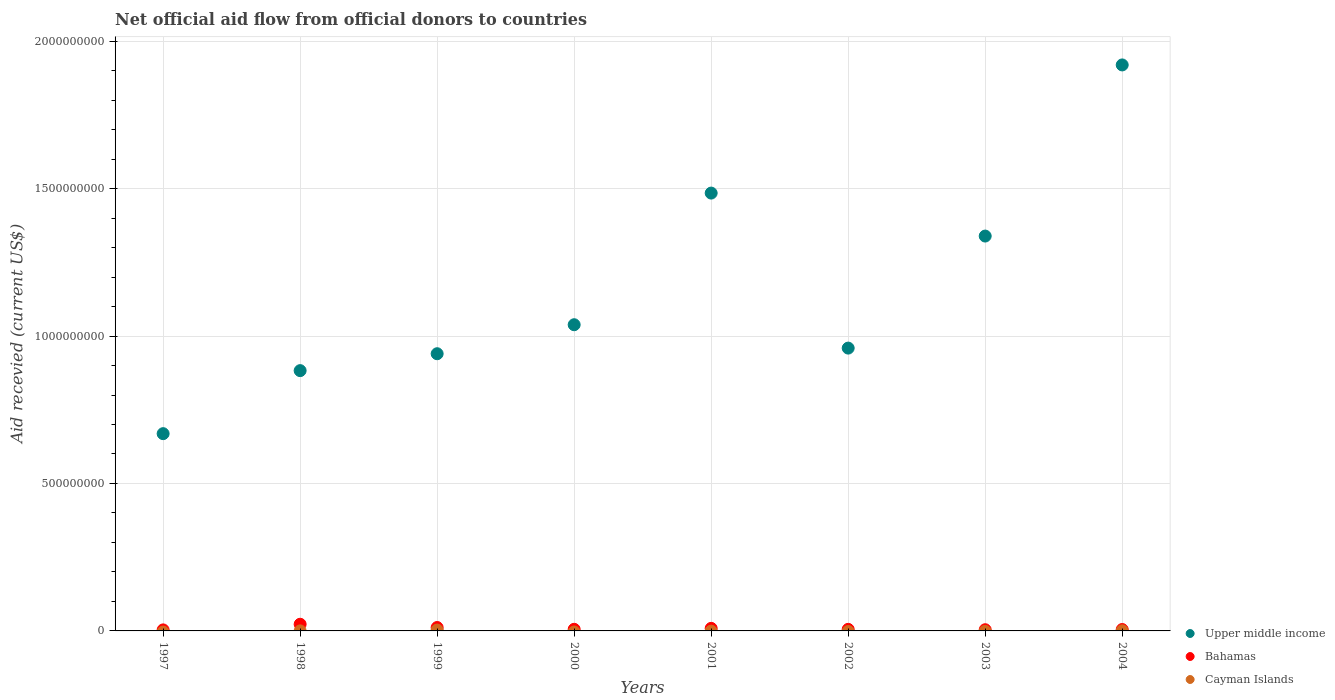Across all years, what is the maximum total aid received in Bahamas?
Your answer should be compact. 2.26e+07. What is the total total aid received in Upper middle income in the graph?
Provide a succinct answer. 9.23e+09. What is the difference between the total aid received in Upper middle income in 2001 and that in 2004?
Keep it short and to the point. -4.35e+08. What is the difference between the total aid received in Upper middle income in 2002 and the total aid received in Bahamas in 1997?
Offer a very short reply. 9.56e+08. What is the average total aid received in Upper middle income per year?
Provide a short and direct response. 1.15e+09. In the year 2004, what is the difference between the total aid received in Bahamas and total aid received in Cayman Islands?
Provide a succinct answer. 4.36e+06. What is the ratio of the total aid received in Bahamas in 2002 to that in 2003?
Give a very brief answer. 1.31. Is the total aid received in Bahamas in 1999 less than that in 2003?
Give a very brief answer. No. What is the difference between the highest and the second highest total aid received in Upper middle income?
Offer a terse response. 4.35e+08. What is the difference between the highest and the lowest total aid received in Upper middle income?
Your answer should be compact. 1.25e+09. Is it the case that in every year, the sum of the total aid received in Cayman Islands and total aid received in Bahamas  is greater than the total aid received in Upper middle income?
Provide a short and direct response. No. Does the total aid received in Upper middle income monotonically increase over the years?
Give a very brief answer. No. Is the total aid received in Upper middle income strictly greater than the total aid received in Bahamas over the years?
Ensure brevity in your answer.  Yes. How many years are there in the graph?
Ensure brevity in your answer.  8. What is the difference between two consecutive major ticks on the Y-axis?
Ensure brevity in your answer.  5.00e+08. Are the values on the major ticks of Y-axis written in scientific E-notation?
Give a very brief answer. No. Does the graph contain grids?
Make the answer very short. Yes. Where does the legend appear in the graph?
Keep it short and to the point. Bottom right. How many legend labels are there?
Give a very brief answer. 3. What is the title of the graph?
Keep it short and to the point. Net official aid flow from official donors to countries. Does "Central African Republic" appear as one of the legend labels in the graph?
Keep it short and to the point. No. What is the label or title of the X-axis?
Give a very brief answer. Years. What is the label or title of the Y-axis?
Make the answer very short. Aid recevied (current US$). What is the Aid recevied (current US$) of Upper middle income in 1997?
Give a very brief answer. 6.69e+08. What is the Aid recevied (current US$) of Bahamas in 1997?
Give a very brief answer. 3.47e+06. What is the Aid recevied (current US$) in Upper middle income in 1998?
Keep it short and to the point. 8.83e+08. What is the Aid recevied (current US$) in Bahamas in 1998?
Keep it short and to the point. 2.26e+07. What is the Aid recevied (current US$) in Cayman Islands in 1998?
Give a very brief answer. 1.60e+05. What is the Aid recevied (current US$) in Upper middle income in 1999?
Your response must be concise. 9.40e+08. What is the Aid recevied (current US$) in Bahamas in 1999?
Your response must be concise. 1.16e+07. What is the Aid recevied (current US$) of Cayman Islands in 1999?
Offer a very short reply. 3.01e+06. What is the Aid recevied (current US$) of Upper middle income in 2000?
Provide a short and direct response. 1.04e+09. What is the Aid recevied (current US$) of Bahamas in 2000?
Keep it short and to the point. 5.47e+06. What is the Aid recevied (current US$) of Upper middle income in 2001?
Make the answer very short. 1.48e+09. What is the Aid recevied (current US$) of Bahamas in 2001?
Provide a succinct answer. 8.68e+06. What is the Aid recevied (current US$) of Cayman Islands in 2001?
Your answer should be very brief. 0. What is the Aid recevied (current US$) in Upper middle income in 2002?
Keep it short and to the point. 9.59e+08. What is the Aid recevied (current US$) of Bahamas in 2002?
Provide a succinct answer. 5.32e+06. What is the Aid recevied (current US$) of Cayman Islands in 2002?
Ensure brevity in your answer.  0. What is the Aid recevied (current US$) of Upper middle income in 2003?
Offer a very short reply. 1.34e+09. What is the Aid recevied (current US$) of Bahamas in 2003?
Provide a short and direct response. 4.07e+06. What is the Aid recevied (current US$) of Upper middle income in 2004?
Provide a short and direct response. 1.92e+09. What is the Aid recevied (current US$) in Bahamas in 2004?
Ensure brevity in your answer.  4.75e+06. Across all years, what is the maximum Aid recevied (current US$) in Upper middle income?
Make the answer very short. 1.92e+09. Across all years, what is the maximum Aid recevied (current US$) of Bahamas?
Provide a succinct answer. 2.26e+07. Across all years, what is the maximum Aid recevied (current US$) in Cayman Islands?
Ensure brevity in your answer.  3.01e+06. Across all years, what is the minimum Aid recevied (current US$) of Upper middle income?
Offer a very short reply. 6.69e+08. Across all years, what is the minimum Aid recevied (current US$) of Bahamas?
Offer a terse response. 3.47e+06. What is the total Aid recevied (current US$) in Upper middle income in the graph?
Make the answer very short. 9.23e+09. What is the total Aid recevied (current US$) in Bahamas in the graph?
Ensure brevity in your answer.  6.59e+07. What is the total Aid recevied (current US$) in Cayman Islands in the graph?
Offer a very short reply. 3.56e+06. What is the difference between the Aid recevied (current US$) in Upper middle income in 1997 and that in 1998?
Offer a terse response. -2.14e+08. What is the difference between the Aid recevied (current US$) in Bahamas in 1997 and that in 1998?
Keep it short and to the point. -1.91e+07. What is the difference between the Aid recevied (current US$) of Upper middle income in 1997 and that in 1999?
Your response must be concise. -2.71e+08. What is the difference between the Aid recevied (current US$) in Bahamas in 1997 and that in 1999?
Provide a short and direct response. -8.09e+06. What is the difference between the Aid recevied (current US$) in Upper middle income in 1997 and that in 2000?
Make the answer very short. -3.69e+08. What is the difference between the Aid recevied (current US$) in Bahamas in 1997 and that in 2000?
Your answer should be very brief. -2.00e+06. What is the difference between the Aid recevied (current US$) in Upper middle income in 1997 and that in 2001?
Ensure brevity in your answer.  -8.16e+08. What is the difference between the Aid recevied (current US$) of Bahamas in 1997 and that in 2001?
Your answer should be very brief. -5.21e+06. What is the difference between the Aid recevied (current US$) of Upper middle income in 1997 and that in 2002?
Your answer should be very brief. -2.90e+08. What is the difference between the Aid recevied (current US$) in Bahamas in 1997 and that in 2002?
Offer a very short reply. -1.85e+06. What is the difference between the Aid recevied (current US$) in Upper middle income in 1997 and that in 2003?
Offer a terse response. -6.70e+08. What is the difference between the Aid recevied (current US$) in Bahamas in 1997 and that in 2003?
Your response must be concise. -6.00e+05. What is the difference between the Aid recevied (current US$) of Upper middle income in 1997 and that in 2004?
Offer a terse response. -1.25e+09. What is the difference between the Aid recevied (current US$) in Bahamas in 1997 and that in 2004?
Ensure brevity in your answer.  -1.28e+06. What is the difference between the Aid recevied (current US$) in Upper middle income in 1998 and that in 1999?
Offer a terse response. -5.73e+07. What is the difference between the Aid recevied (current US$) of Bahamas in 1998 and that in 1999?
Give a very brief answer. 1.10e+07. What is the difference between the Aid recevied (current US$) in Cayman Islands in 1998 and that in 1999?
Offer a terse response. -2.85e+06. What is the difference between the Aid recevied (current US$) of Upper middle income in 1998 and that in 2000?
Ensure brevity in your answer.  -1.56e+08. What is the difference between the Aid recevied (current US$) of Bahamas in 1998 and that in 2000?
Give a very brief answer. 1.71e+07. What is the difference between the Aid recevied (current US$) in Upper middle income in 1998 and that in 2001?
Provide a short and direct response. -6.02e+08. What is the difference between the Aid recevied (current US$) in Bahamas in 1998 and that in 2001?
Provide a short and direct response. 1.39e+07. What is the difference between the Aid recevied (current US$) of Upper middle income in 1998 and that in 2002?
Offer a terse response. -7.64e+07. What is the difference between the Aid recevied (current US$) in Bahamas in 1998 and that in 2002?
Offer a terse response. 1.73e+07. What is the difference between the Aid recevied (current US$) of Upper middle income in 1998 and that in 2003?
Offer a terse response. -4.56e+08. What is the difference between the Aid recevied (current US$) of Bahamas in 1998 and that in 2003?
Your answer should be compact. 1.85e+07. What is the difference between the Aid recevied (current US$) in Upper middle income in 1998 and that in 2004?
Ensure brevity in your answer.  -1.04e+09. What is the difference between the Aid recevied (current US$) in Bahamas in 1998 and that in 2004?
Provide a succinct answer. 1.79e+07. What is the difference between the Aid recevied (current US$) of Upper middle income in 1999 and that in 2000?
Your answer should be very brief. -9.83e+07. What is the difference between the Aid recevied (current US$) in Bahamas in 1999 and that in 2000?
Your answer should be compact. 6.09e+06. What is the difference between the Aid recevied (current US$) of Upper middle income in 1999 and that in 2001?
Your response must be concise. -5.45e+08. What is the difference between the Aid recevied (current US$) of Bahamas in 1999 and that in 2001?
Give a very brief answer. 2.88e+06. What is the difference between the Aid recevied (current US$) of Upper middle income in 1999 and that in 2002?
Your answer should be compact. -1.91e+07. What is the difference between the Aid recevied (current US$) of Bahamas in 1999 and that in 2002?
Give a very brief answer. 6.24e+06. What is the difference between the Aid recevied (current US$) of Upper middle income in 1999 and that in 2003?
Your answer should be very brief. -3.99e+08. What is the difference between the Aid recevied (current US$) of Bahamas in 1999 and that in 2003?
Provide a short and direct response. 7.49e+06. What is the difference between the Aid recevied (current US$) of Upper middle income in 1999 and that in 2004?
Offer a very short reply. -9.79e+08. What is the difference between the Aid recevied (current US$) in Bahamas in 1999 and that in 2004?
Your answer should be compact. 6.81e+06. What is the difference between the Aid recevied (current US$) in Cayman Islands in 1999 and that in 2004?
Offer a terse response. 2.62e+06. What is the difference between the Aid recevied (current US$) in Upper middle income in 2000 and that in 2001?
Provide a succinct answer. -4.46e+08. What is the difference between the Aid recevied (current US$) of Bahamas in 2000 and that in 2001?
Give a very brief answer. -3.21e+06. What is the difference between the Aid recevied (current US$) in Upper middle income in 2000 and that in 2002?
Provide a short and direct response. 7.93e+07. What is the difference between the Aid recevied (current US$) of Bahamas in 2000 and that in 2002?
Provide a short and direct response. 1.50e+05. What is the difference between the Aid recevied (current US$) of Upper middle income in 2000 and that in 2003?
Give a very brief answer. -3.01e+08. What is the difference between the Aid recevied (current US$) of Bahamas in 2000 and that in 2003?
Keep it short and to the point. 1.40e+06. What is the difference between the Aid recevied (current US$) of Upper middle income in 2000 and that in 2004?
Your answer should be very brief. -8.81e+08. What is the difference between the Aid recevied (current US$) in Bahamas in 2000 and that in 2004?
Keep it short and to the point. 7.20e+05. What is the difference between the Aid recevied (current US$) of Upper middle income in 2001 and that in 2002?
Your answer should be compact. 5.26e+08. What is the difference between the Aid recevied (current US$) in Bahamas in 2001 and that in 2002?
Provide a short and direct response. 3.36e+06. What is the difference between the Aid recevied (current US$) of Upper middle income in 2001 and that in 2003?
Your answer should be very brief. 1.46e+08. What is the difference between the Aid recevied (current US$) in Bahamas in 2001 and that in 2003?
Give a very brief answer. 4.61e+06. What is the difference between the Aid recevied (current US$) of Upper middle income in 2001 and that in 2004?
Provide a succinct answer. -4.35e+08. What is the difference between the Aid recevied (current US$) in Bahamas in 2001 and that in 2004?
Your response must be concise. 3.93e+06. What is the difference between the Aid recevied (current US$) of Upper middle income in 2002 and that in 2003?
Provide a short and direct response. -3.80e+08. What is the difference between the Aid recevied (current US$) of Bahamas in 2002 and that in 2003?
Your answer should be very brief. 1.25e+06. What is the difference between the Aid recevied (current US$) in Upper middle income in 2002 and that in 2004?
Your answer should be very brief. -9.60e+08. What is the difference between the Aid recevied (current US$) in Bahamas in 2002 and that in 2004?
Offer a terse response. 5.70e+05. What is the difference between the Aid recevied (current US$) of Upper middle income in 2003 and that in 2004?
Your answer should be compact. -5.80e+08. What is the difference between the Aid recevied (current US$) of Bahamas in 2003 and that in 2004?
Your answer should be very brief. -6.80e+05. What is the difference between the Aid recevied (current US$) in Upper middle income in 1997 and the Aid recevied (current US$) in Bahamas in 1998?
Provide a succinct answer. 6.46e+08. What is the difference between the Aid recevied (current US$) in Upper middle income in 1997 and the Aid recevied (current US$) in Cayman Islands in 1998?
Give a very brief answer. 6.69e+08. What is the difference between the Aid recevied (current US$) in Bahamas in 1997 and the Aid recevied (current US$) in Cayman Islands in 1998?
Provide a short and direct response. 3.31e+06. What is the difference between the Aid recevied (current US$) of Upper middle income in 1997 and the Aid recevied (current US$) of Bahamas in 1999?
Your answer should be very brief. 6.57e+08. What is the difference between the Aid recevied (current US$) of Upper middle income in 1997 and the Aid recevied (current US$) of Cayman Islands in 1999?
Your answer should be compact. 6.66e+08. What is the difference between the Aid recevied (current US$) in Upper middle income in 1997 and the Aid recevied (current US$) in Bahamas in 2000?
Give a very brief answer. 6.63e+08. What is the difference between the Aid recevied (current US$) of Upper middle income in 1997 and the Aid recevied (current US$) of Bahamas in 2001?
Your answer should be compact. 6.60e+08. What is the difference between the Aid recevied (current US$) of Upper middle income in 1997 and the Aid recevied (current US$) of Bahamas in 2002?
Ensure brevity in your answer.  6.64e+08. What is the difference between the Aid recevied (current US$) in Upper middle income in 1997 and the Aid recevied (current US$) in Bahamas in 2003?
Offer a very short reply. 6.65e+08. What is the difference between the Aid recevied (current US$) in Upper middle income in 1997 and the Aid recevied (current US$) in Bahamas in 2004?
Give a very brief answer. 6.64e+08. What is the difference between the Aid recevied (current US$) of Upper middle income in 1997 and the Aid recevied (current US$) of Cayman Islands in 2004?
Keep it short and to the point. 6.69e+08. What is the difference between the Aid recevied (current US$) in Bahamas in 1997 and the Aid recevied (current US$) in Cayman Islands in 2004?
Provide a short and direct response. 3.08e+06. What is the difference between the Aid recevied (current US$) of Upper middle income in 1998 and the Aid recevied (current US$) of Bahamas in 1999?
Your answer should be compact. 8.71e+08. What is the difference between the Aid recevied (current US$) in Upper middle income in 1998 and the Aid recevied (current US$) in Cayman Islands in 1999?
Ensure brevity in your answer.  8.80e+08. What is the difference between the Aid recevied (current US$) of Bahamas in 1998 and the Aid recevied (current US$) of Cayman Islands in 1999?
Your response must be concise. 1.96e+07. What is the difference between the Aid recevied (current US$) in Upper middle income in 1998 and the Aid recevied (current US$) in Bahamas in 2000?
Your answer should be compact. 8.77e+08. What is the difference between the Aid recevied (current US$) of Upper middle income in 1998 and the Aid recevied (current US$) of Bahamas in 2001?
Your response must be concise. 8.74e+08. What is the difference between the Aid recevied (current US$) in Upper middle income in 1998 and the Aid recevied (current US$) in Bahamas in 2002?
Provide a succinct answer. 8.77e+08. What is the difference between the Aid recevied (current US$) of Upper middle income in 1998 and the Aid recevied (current US$) of Bahamas in 2003?
Make the answer very short. 8.79e+08. What is the difference between the Aid recevied (current US$) of Upper middle income in 1998 and the Aid recevied (current US$) of Bahamas in 2004?
Give a very brief answer. 8.78e+08. What is the difference between the Aid recevied (current US$) of Upper middle income in 1998 and the Aid recevied (current US$) of Cayman Islands in 2004?
Provide a succinct answer. 8.82e+08. What is the difference between the Aid recevied (current US$) of Bahamas in 1998 and the Aid recevied (current US$) of Cayman Islands in 2004?
Offer a very short reply. 2.22e+07. What is the difference between the Aid recevied (current US$) in Upper middle income in 1999 and the Aid recevied (current US$) in Bahamas in 2000?
Your answer should be very brief. 9.35e+08. What is the difference between the Aid recevied (current US$) of Upper middle income in 1999 and the Aid recevied (current US$) of Bahamas in 2001?
Make the answer very short. 9.31e+08. What is the difference between the Aid recevied (current US$) in Upper middle income in 1999 and the Aid recevied (current US$) in Bahamas in 2002?
Provide a short and direct response. 9.35e+08. What is the difference between the Aid recevied (current US$) in Upper middle income in 1999 and the Aid recevied (current US$) in Bahamas in 2003?
Your answer should be compact. 9.36e+08. What is the difference between the Aid recevied (current US$) of Upper middle income in 1999 and the Aid recevied (current US$) of Bahamas in 2004?
Offer a very short reply. 9.35e+08. What is the difference between the Aid recevied (current US$) of Upper middle income in 1999 and the Aid recevied (current US$) of Cayman Islands in 2004?
Your answer should be very brief. 9.40e+08. What is the difference between the Aid recevied (current US$) of Bahamas in 1999 and the Aid recevied (current US$) of Cayman Islands in 2004?
Your answer should be very brief. 1.12e+07. What is the difference between the Aid recevied (current US$) of Upper middle income in 2000 and the Aid recevied (current US$) of Bahamas in 2001?
Give a very brief answer. 1.03e+09. What is the difference between the Aid recevied (current US$) in Upper middle income in 2000 and the Aid recevied (current US$) in Bahamas in 2002?
Ensure brevity in your answer.  1.03e+09. What is the difference between the Aid recevied (current US$) of Upper middle income in 2000 and the Aid recevied (current US$) of Bahamas in 2003?
Give a very brief answer. 1.03e+09. What is the difference between the Aid recevied (current US$) in Upper middle income in 2000 and the Aid recevied (current US$) in Bahamas in 2004?
Provide a short and direct response. 1.03e+09. What is the difference between the Aid recevied (current US$) in Upper middle income in 2000 and the Aid recevied (current US$) in Cayman Islands in 2004?
Give a very brief answer. 1.04e+09. What is the difference between the Aid recevied (current US$) in Bahamas in 2000 and the Aid recevied (current US$) in Cayman Islands in 2004?
Offer a very short reply. 5.08e+06. What is the difference between the Aid recevied (current US$) in Upper middle income in 2001 and the Aid recevied (current US$) in Bahamas in 2002?
Keep it short and to the point. 1.48e+09. What is the difference between the Aid recevied (current US$) of Upper middle income in 2001 and the Aid recevied (current US$) of Bahamas in 2003?
Offer a very short reply. 1.48e+09. What is the difference between the Aid recevied (current US$) of Upper middle income in 2001 and the Aid recevied (current US$) of Bahamas in 2004?
Your response must be concise. 1.48e+09. What is the difference between the Aid recevied (current US$) of Upper middle income in 2001 and the Aid recevied (current US$) of Cayman Islands in 2004?
Keep it short and to the point. 1.48e+09. What is the difference between the Aid recevied (current US$) of Bahamas in 2001 and the Aid recevied (current US$) of Cayman Islands in 2004?
Provide a short and direct response. 8.29e+06. What is the difference between the Aid recevied (current US$) in Upper middle income in 2002 and the Aid recevied (current US$) in Bahamas in 2003?
Make the answer very short. 9.55e+08. What is the difference between the Aid recevied (current US$) in Upper middle income in 2002 and the Aid recevied (current US$) in Bahamas in 2004?
Offer a terse response. 9.54e+08. What is the difference between the Aid recevied (current US$) of Upper middle income in 2002 and the Aid recevied (current US$) of Cayman Islands in 2004?
Your response must be concise. 9.59e+08. What is the difference between the Aid recevied (current US$) of Bahamas in 2002 and the Aid recevied (current US$) of Cayman Islands in 2004?
Your answer should be very brief. 4.93e+06. What is the difference between the Aid recevied (current US$) of Upper middle income in 2003 and the Aid recevied (current US$) of Bahamas in 2004?
Ensure brevity in your answer.  1.33e+09. What is the difference between the Aid recevied (current US$) of Upper middle income in 2003 and the Aid recevied (current US$) of Cayman Islands in 2004?
Give a very brief answer. 1.34e+09. What is the difference between the Aid recevied (current US$) in Bahamas in 2003 and the Aid recevied (current US$) in Cayman Islands in 2004?
Offer a terse response. 3.68e+06. What is the average Aid recevied (current US$) of Upper middle income per year?
Provide a succinct answer. 1.15e+09. What is the average Aid recevied (current US$) of Bahamas per year?
Keep it short and to the point. 8.24e+06. What is the average Aid recevied (current US$) of Cayman Islands per year?
Make the answer very short. 4.45e+05. In the year 1997, what is the difference between the Aid recevied (current US$) in Upper middle income and Aid recevied (current US$) in Bahamas?
Your response must be concise. 6.65e+08. In the year 1998, what is the difference between the Aid recevied (current US$) in Upper middle income and Aid recevied (current US$) in Bahamas?
Ensure brevity in your answer.  8.60e+08. In the year 1998, what is the difference between the Aid recevied (current US$) in Upper middle income and Aid recevied (current US$) in Cayman Islands?
Provide a short and direct response. 8.82e+08. In the year 1998, what is the difference between the Aid recevied (current US$) of Bahamas and Aid recevied (current US$) of Cayman Islands?
Your answer should be compact. 2.24e+07. In the year 1999, what is the difference between the Aid recevied (current US$) in Upper middle income and Aid recevied (current US$) in Bahamas?
Ensure brevity in your answer.  9.28e+08. In the year 1999, what is the difference between the Aid recevied (current US$) of Upper middle income and Aid recevied (current US$) of Cayman Islands?
Your answer should be compact. 9.37e+08. In the year 1999, what is the difference between the Aid recevied (current US$) of Bahamas and Aid recevied (current US$) of Cayman Islands?
Offer a very short reply. 8.55e+06. In the year 2000, what is the difference between the Aid recevied (current US$) of Upper middle income and Aid recevied (current US$) of Bahamas?
Provide a short and direct response. 1.03e+09. In the year 2001, what is the difference between the Aid recevied (current US$) in Upper middle income and Aid recevied (current US$) in Bahamas?
Make the answer very short. 1.48e+09. In the year 2002, what is the difference between the Aid recevied (current US$) of Upper middle income and Aid recevied (current US$) of Bahamas?
Give a very brief answer. 9.54e+08. In the year 2003, what is the difference between the Aid recevied (current US$) of Upper middle income and Aid recevied (current US$) of Bahamas?
Provide a succinct answer. 1.33e+09. In the year 2004, what is the difference between the Aid recevied (current US$) in Upper middle income and Aid recevied (current US$) in Bahamas?
Provide a short and direct response. 1.91e+09. In the year 2004, what is the difference between the Aid recevied (current US$) of Upper middle income and Aid recevied (current US$) of Cayman Islands?
Offer a very short reply. 1.92e+09. In the year 2004, what is the difference between the Aid recevied (current US$) in Bahamas and Aid recevied (current US$) in Cayman Islands?
Your answer should be very brief. 4.36e+06. What is the ratio of the Aid recevied (current US$) of Upper middle income in 1997 to that in 1998?
Provide a succinct answer. 0.76. What is the ratio of the Aid recevied (current US$) of Bahamas in 1997 to that in 1998?
Your answer should be very brief. 0.15. What is the ratio of the Aid recevied (current US$) of Upper middle income in 1997 to that in 1999?
Keep it short and to the point. 0.71. What is the ratio of the Aid recevied (current US$) of Bahamas in 1997 to that in 1999?
Your answer should be very brief. 0.3. What is the ratio of the Aid recevied (current US$) of Upper middle income in 1997 to that in 2000?
Give a very brief answer. 0.64. What is the ratio of the Aid recevied (current US$) in Bahamas in 1997 to that in 2000?
Offer a very short reply. 0.63. What is the ratio of the Aid recevied (current US$) in Upper middle income in 1997 to that in 2001?
Your answer should be very brief. 0.45. What is the ratio of the Aid recevied (current US$) in Bahamas in 1997 to that in 2001?
Your answer should be very brief. 0.4. What is the ratio of the Aid recevied (current US$) in Upper middle income in 1997 to that in 2002?
Offer a very short reply. 0.7. What is the ratio of the Aid recevied (current US$) in Bahamas in 1997 to that in 2002?
Your answer should be compact. 0.65. What is the ratio of the Aid recevied (current US$) of Upper middle income in 1997 to that in 2003?
Provide a short and direct response. 0.5. What is the ratio of the Aid recevied (current US$) of Bahamas in 1997 to that in 2003?
Offer a very short reply. 0.85. What is the ratio of the Aid recevied (current US$) of Upper middle income in 1997 to that in 2004?
Your answer should be compact. 0.35. What is the ratio of the Aid recevied (current US$) in Bahamas in 1997 to that in 2004?
Provide a short and direct response. 0.73. What is the ratio of the Aid recevied (current US$) in Upper middle income in 1998 to that in 1999?
Your answer should be very brief. 0.94. What is the ratio of the Aid recevied (current US$) in Bahamas in 1998 to that in 1999?
Your answer should be very brief. 1.96. What is the ratio of the Aid recevied (current US$) of Cayman Islands in 1998 to that in 1999?
Make the answer very short. 0.05. What is the ratio of the Aid recevied (current US$) in Upper middle income in 1998 to that in 2000?
Your answer should be very brief. 0.85. What is the ratio of the Aid recevied (current US$) in Bahamas in 1998 to that in 2000?
Give a very brief answer. 4.13. What is the ratio of the Aid recevied (current US$) of Upper middle income in 1998 to that in 2001?
Keep it short and to the point. 0.59. What is the ratio of the Aid recevied (current US$) in Bahamas in 1998 to that in 2001?
Provide a succinct answer. 2.6. What is the ratio of the Aid recevied (current US$) of Upper middle income in 1998 to that in 2002?
Your response must be concise. 0.92. What is the ratio of the Aid recevied (current US$) in Bahamas in 1998 to that in 2002?
Make the answer very short. 4.25. What is the ratio of the Aid recevied (current US$) in Upper middle income in 1998 to that in 2003?
Keep it short and to the point. 0.66. What is the ratio of the Aid recevied (current US$) of Bahamas in 1998 to that in 2003?
Your answer should be compact. 5.56. What is the ratio of the Aid recevied (current US$) of Upper middle income in 1998 to that in 2004?
Your answer should be compact. 0.46. What is the ratio of the Aid recevied (current US$) of Bahamas in 1998 to that in 2004?
Ensure brevity in your answer.  4.76. What is the ratio of the Aid recevied (current US$) of Cayman Islands in 1998 to that in 2004?
Your response must be concise. 0.41. What is the ratio of the Aid recevied (current US$) of Upper middle income in 1999 to that in 2000?
Ensure brevity in your answer.  0.91. What is the ratio of the Aid recevied (current US$) of Bahamas in 1999 to that in 2000?
Make the answer very short. 2.11. What is the ratio of the Aid recevied (current US$) of Upper middle income in 1999 to that in 2001?
Provide a succinct answer. 0.63. What is the ratio of the Aid recevied (current US$) in Bahamas in 1999 to that in 2001?
Offer a very short reply. 1.33. What is the ratio of the Aid recevied (current US$) in Upper middle income in 1999 to that in 2002?
Provide a short and direct response. 0.98. What is the ratio of the Aid recevied (current US$) in Bahamas in 1999 to that in 2002?
Offer a terse response. 2.17. What is the ratio of the Aid recevied (current US$) in Upper middle income in 1999 to that in 2003?
Offer a terse response. 0.7. What is the ratio of the Aid recevied (current US$) in Bahamas in 1999 to that in 2003?
Your answer should be very brief. 2.84. What is the ratio of the Aid recevied (current US$) in Upper middle income in 1999 to that in 2004?
Your response must be concise. 0.49. What is the ratio of the Aid recevied (current US$) in Bahamas in 1999 to that in 2004?
Your answer should be very brief. 2.43. What is the ratio of the Aid recevied (current US$) of Cayman Islands in 1999 to that in 2004?
Give a very brief answer. 7.72. What is the ratio of the Aid recevied (current US$) of Upper middle income in 2000 to that in 2001?
Give a very brief answer. 0.7. What is the ratio of the Aid recevied (current US$) in Bahamas in 2000 to that in 2001?
Your answer should be very brief. 0.63. What is the ratio of the Aid recevied (current US$) of Upper middle income in 2000 to that in 2002?
Your answer should be compact. 1.08. What is the ratio of the Aid recevied (current US$) of Bahamas in 2000 to that in 2002?
Give a very brief answer. 1.03. What is the ratio of the Aid recevied (current US$) of Upper middle income in 2000 to that in 2003?
Ensure brevity in your answer.  0.78. What is the ratio of the Aid recevied (current US$) of Bahamas in 2000 to that in 2003?
Ensure brevity in your answer.  1.34. What is the ratio of the Aid recevied (current US$) in Upper middle income in 2000 to that in 2004?
Make the answer very short. 0.54. What is the ratio of the Aid recevied (current US$) in Bahamas in 2000 to that in 2004?
Give a very brief answer. 1.15. What is the ratio of the Aid recevied (current US$) of Upper middle income in 2001 to that in 2002?
Provide a succinct answer. 1.55. What is the ratio of the Aid recevied (current US$) in Bahamas in 2001 to that in 2002?
Your response must be concise. 1.63. What is the ratio of the Aid recevied (current US$) in Upper middle income in 2001 to that in 2003?
Your response must be concise. 1.11. What is the ratio of the Aid recevied (current US$) in Bahamas in 2001 to that in 2003?
Make the answer very short. 2.13. What is the ratio of the Aid recevied (current US$) of Upper middle income in 2001 to that in 2004?
Your answer should be compact. 0.77. What is the ratio of the Aid recevied (current US$) in Bahamas in 2001 to that in 2004?
Keep it short and to the point. 1.83. What is the ratio of the Aid recevied (current US$) in Upper middle income in 2002 to that in 2003?
Ensure brevity in your answer.  0.72. What is the ratio of the Aid recevied (current US$) in Bahamas in 2002 to that in 2003?
Offer a terse response. 1.31. What is the ratio of the Aid recevied (current US$) of Upper middle income in 2002 to that in 2004?
Give a very brief answer. 0.5. What is the ratio of the Aid recevied (current US$) in Bahamas in 2002 to that in 2004?
Offer a terse response. 1.12. What is the ratio of the Aid recevied (current US$) of Upper middle income in 2003 to that in 2004?
Provide a short and direct response. 0.7. What is the ratio of the Aid recevied (current US$) in Bahamas in 2003 to that in 2004?
Keep it short and to the point. 0.86. What is the difference between the highest and the second highest Aid recevied (current US$) of Upper middle income?
Your response must be concise. 4.35e+08. What is the difference between the highest and the second highest Aid recevied (current US$) of Bahamas?
Your answer should be very brief. 1.10e+07. What is the difference between the highest and the second highest Aid recevied (current US$) of Cayman Islands?
Provide a short and direct response. 2.62e+06. What is the difference between the highest and the lowest Aid recevied (current US$) in Upper middle income?
Offer a very short reply. 1.25e+09. What is the difference between the highest and the lowest Aid recevied (current US$) in Bahamas?
Your answer should be very brief. 1.91e+07. What is the difference between the highest and the lowest Aid recevied (current US$) of Cayman Islands?
Offer a terse response. 3.01e+06. 